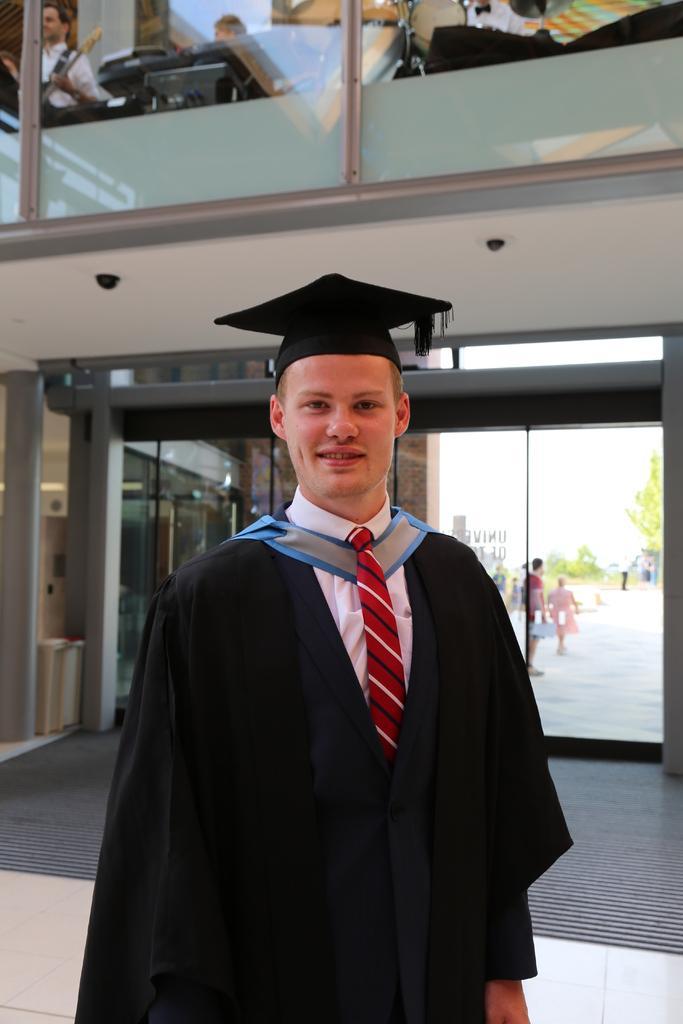Please provide a concise description of this image. In this picture there is a man who is wearing cap jacket, shirt and tie. In the back I can see the door, trees, plants, grass, people and sky. At the top I can see some people who are playing the drum, piano and other musical instrument. 